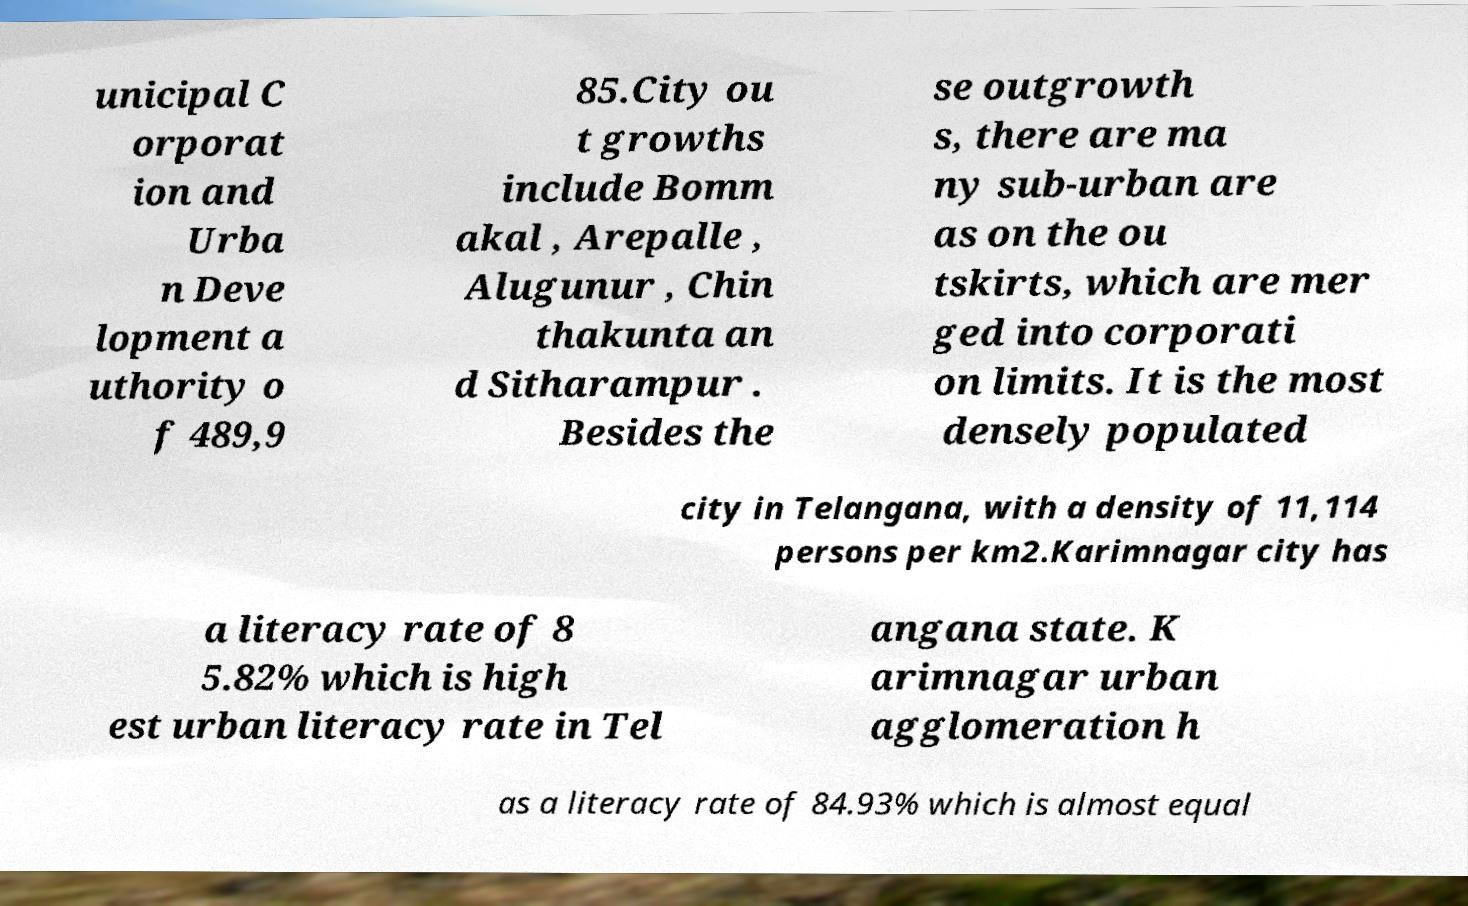Can you read and provide the text displayed in the image?This photo seems to have some interesting text. Can you extract and type it out for me? unicipal C orporat ion and Urba n Deve lopment a uthority o f 489,9 85.City ou t growths include Bomm akal , Arepalle , Alugunur , Chin thakunta an d Sitharampur . Besides the se outgrowth s, there are ma ny sub-urban are as on the ou tskirts, which are mer ged into corporati on limits. It is the most densely populated city in Telangana, with a density of 11,114 persons per km2.Karimnagar city has a literacy rate of 8 5.82% which is high est urban literacy rate in Tel angana state. K arimnagar urban agglomeration h as a literacy rate of 84.93% which is almost equal 